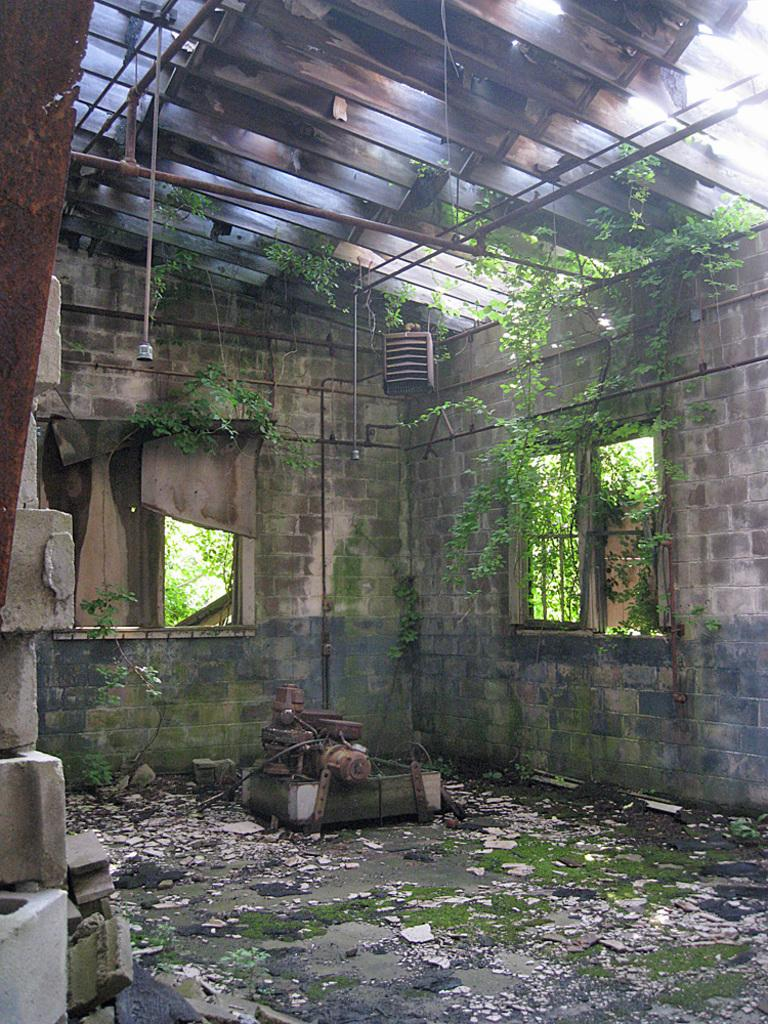What type of room is shown in the image? The image shows an inside view of a damaged room. What is located in the front of the image? There is a wall and windows visible in the front of the image. What type of lighting is present in the room? There are hanging lights in the room. What is the condition of the roof in the image? The roof appears to be damaged or shed. Can you describe the goose that is shaking the colorful umbrella in the image? There is no goose or umbrella present in the image; it shows an inside view of a damaged room with a wall, windows, hanging lights, and a damaged roof. 